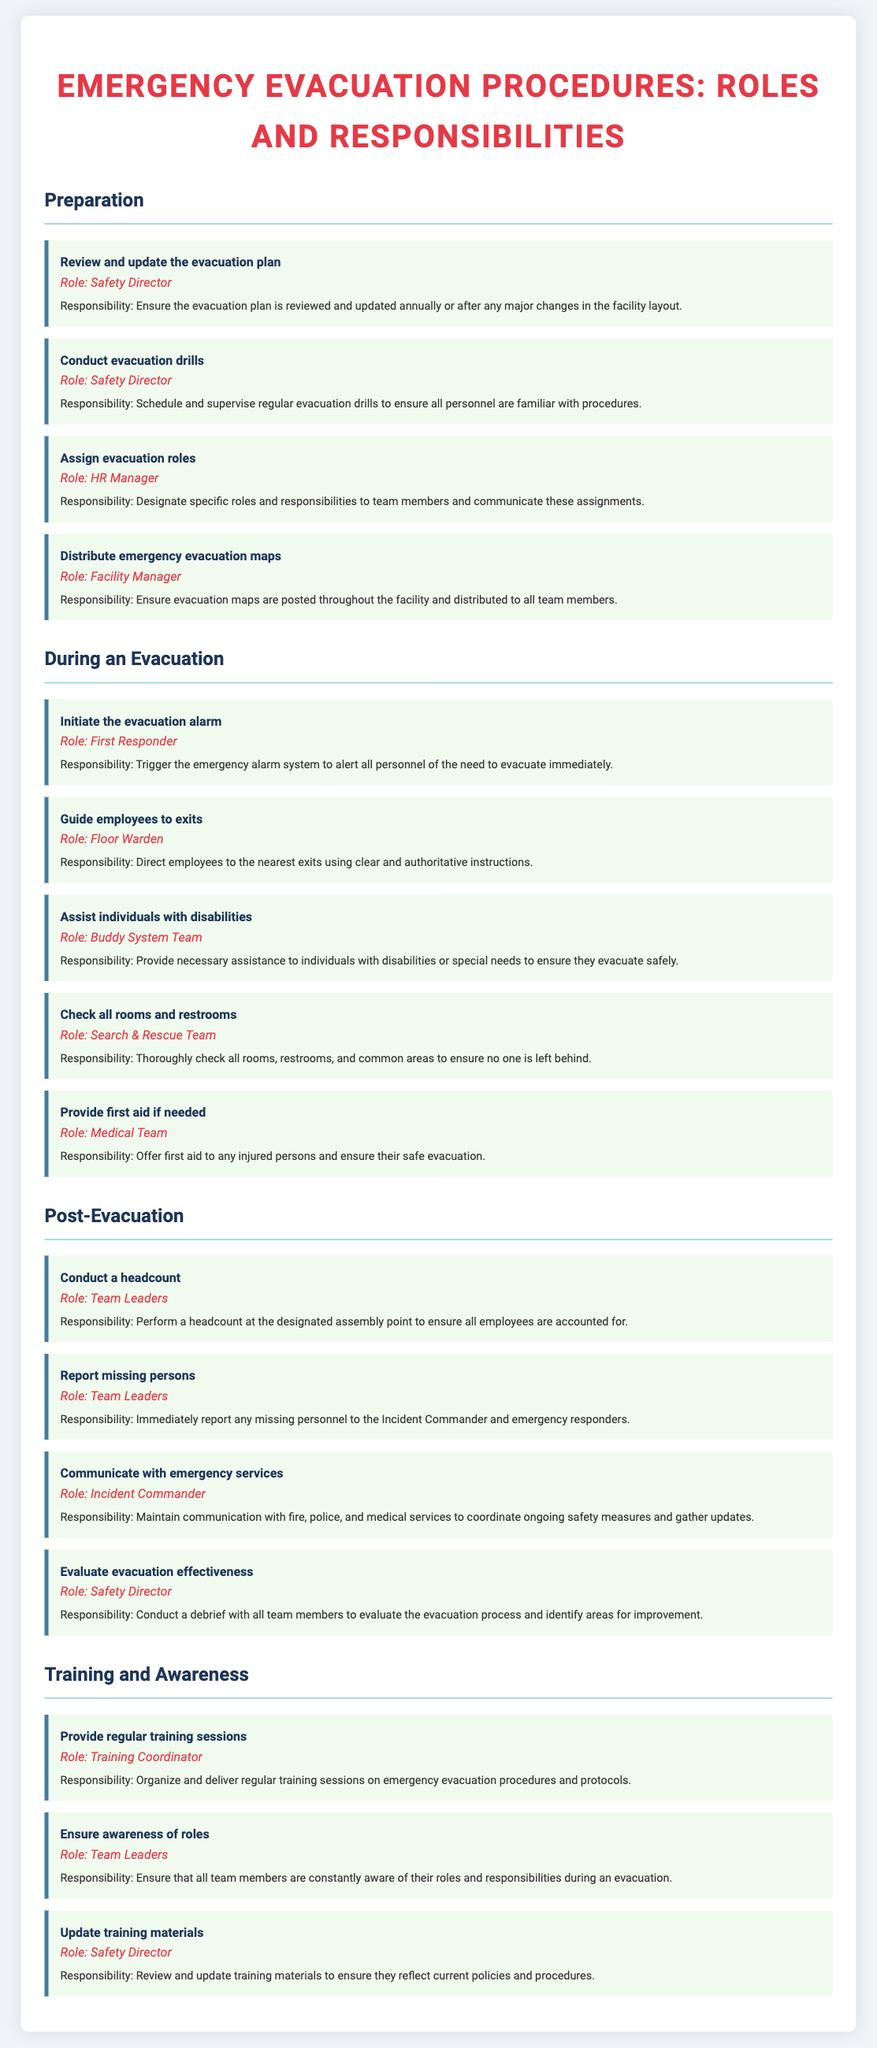what is the role responsible for reviewing and updating the evacuation plan? The role responsible for this task is specified to be the Safety Director in the document.
Answer: Safety Director how many responsibilities are listed under "During an Evacuation"? The document provides five specific responsibilities under this section that are assigned to different roles.
Answer: five who initiates the evacuation alarm? In the document, the task of initiating the evacuation alarm is assigned to the First Responder.
Answer: First Responder what must Team Leaders do during the post-evacuation phase? Team Leaders are responsible for conducting a headcount and reporting missing persons during this phase.
Answer: conduct a headcount and report missing persons which role is responsible for evaluating evacuation effectiveness? The evaluation of evacuation effectiveness is the responsibility of the Safety Director according to the checklist.
Answer: Safety Director what is the task assigned to the Training Coordinator? The Training Coordinator is tasked with organizing and delivering regular training sessions on emergency evacuation procedures.
Answer: provide regular training sessions how often should evacuation drills be conducted? The document states that evacuation drills should be scheduled regularly to ensure familiarity with procedures.
Answer: regularly who is in charge of maintaining communication with emergency services? The role responsible for this is the Incident Commander as detailed in the document.
Answer: Incident Commander 